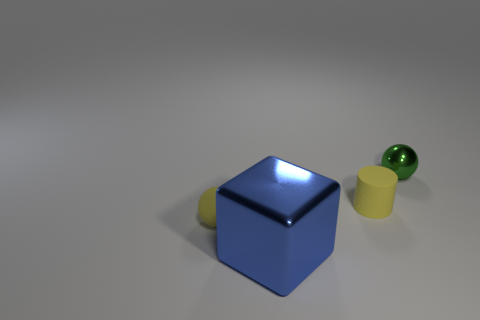Is there a thing of the same color as the matte cylinder?
Ensure brevity in your answer.  Yes. Do the small cylinder and the sphere to the left of the small green object have the same color?
Make the answer very short. Yes. There is a tiny thing that is the same color as the tiny matte cylinder; what is it made of?
Offer a terse response. Rubber. Do the matte ball and the matte cylinder have the same color?
Keep it short and to the point. Yes. Is there anything else that is the same shape as the large metallic object?
Your answer should be very brief. No. How many small balls have the same color as the cylinder?
Ensure brevity in your answer.  1. What is the color of the matte thing that is behind the sphere that is to the left of the tiny green sphere behind the blue block?
Make the answer very short. Yellow. Is the material of the large cube the same as the green object?
Provide a succinct answer. Yes. Is the small green object the same shape as the blue metallic thing?
Your answer should be very brief. No. Are there an equal number of small green objects behind the tiny green metallic sphere and blue metal objects to the left of the large blue metallic thing?
Your response must be concise. Yes. 